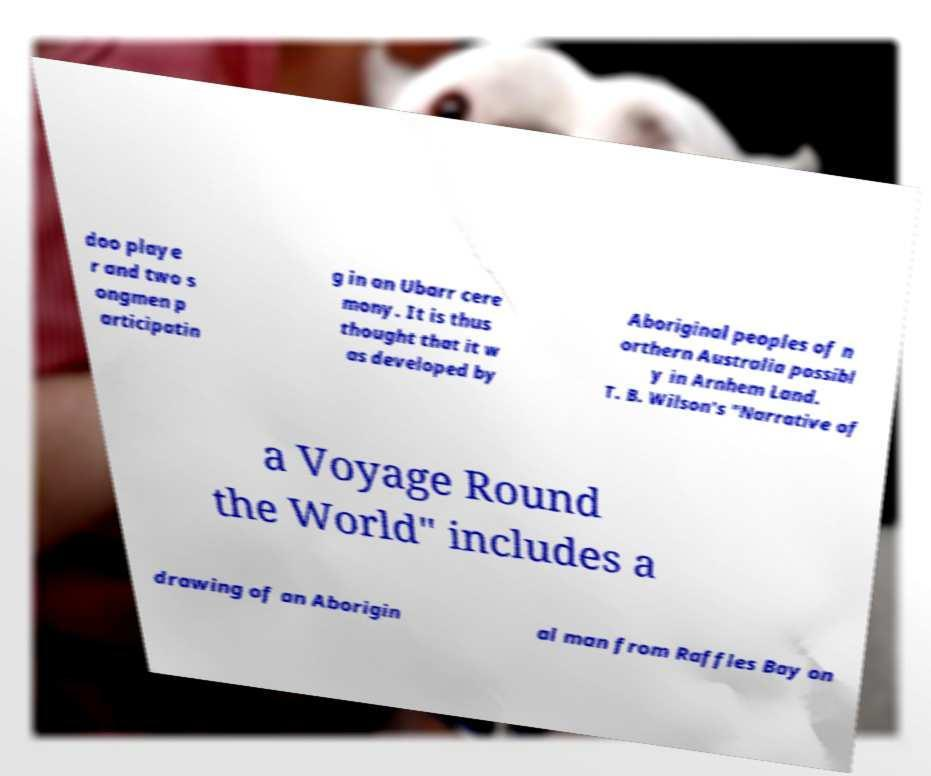Can you read and provide the text displayed in the image?This photo seems to have some interesting text. Can you extract and type it out for me? doo playe r and two s ongmen p articipatin g in an Ubarr cere mony. It is thus thought that it w as developed by Aboriginal peoples of n orthern Australia possibl y in Arnhem Land. T. B. Wilson's "Narrative of a Voyage Round the World" includes a drawing of an Aborigin al man from Raffles Bay on 